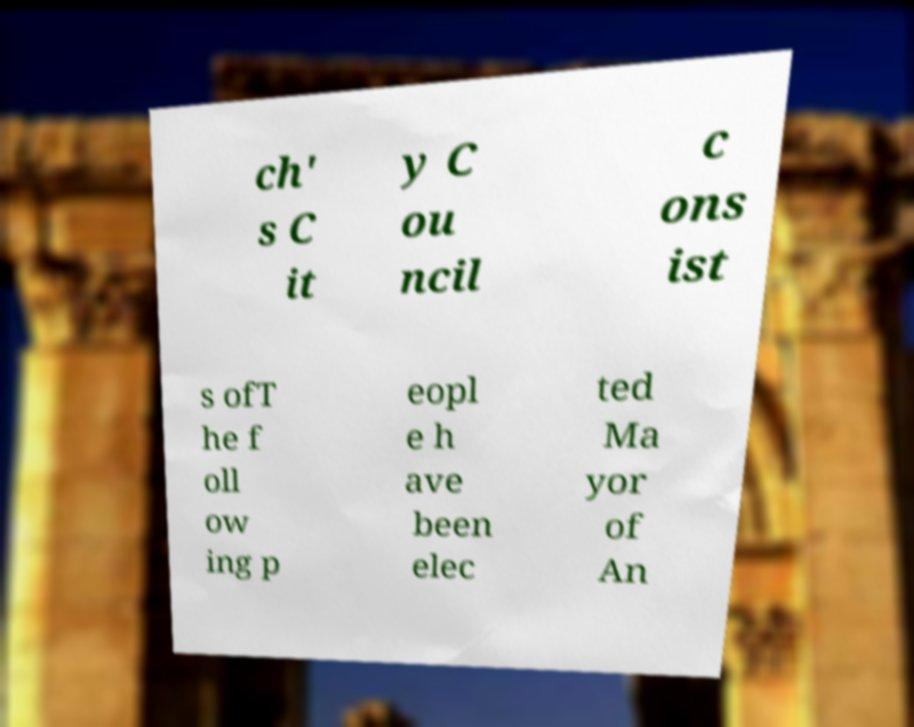Can you accurately transcribe the text from the provided image for me? ch' s C it y C ou ncil c ons ist s ofT he f oll ow ing p eopl e h ave been elec ted Ma yor of An 